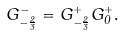<formula> <loc_0><loc_0><loc_500><loc_500>G _ { - { \frac { 2 } { 3 } } } ^ { - } = G _ { - { \frac { 2 } { 3 } } } ^ { + } { G _ { 0 } ^ { + } } .</formula> 